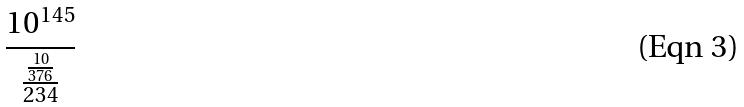<formula> <loc_0><loc_0><loc_500><loc_500>\frac { 1 0 ^ { 1 4 5 } } { \frac { \frac { 1 0 } { 3 7 6 } } { 2 3 4 } }</formula> 